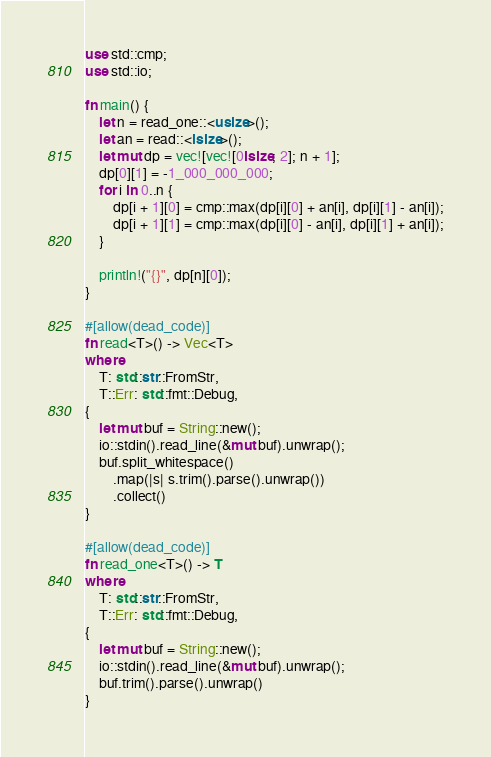<code> <loc_0><loc_0><loc_500><loc_500><_Rust_>use std::cmp;
use std::io;

fn main() {
    let n = read_one::<usize>();
    let an = read::<isize>();
    let mut dp = vec![vec![0isize; 2]; n + 1];
    dp[0][1] = -1_000_000_000;
    for i in 0..n {
        dp[i + 1][0] = cmp::max(dp[i][0] + an[i], dp[i][1] - an[i]);
        dp[i + 1][1] = cmp::max(dp[i][0] - an[i], dp[i][1] + an[i]);
    }

    println!("{}", dp[n][0]);
}

#[allow(dead_code)]
fn read<T>() -> Vec<T>
where
    T: std::str::FromStr,
    T::Err: std::fmt::Debug,
{
    let mut buf = String::new();
    io::stdin().read_line(&mut buf).unwrap();
    buf.split_whitespace()
        .map(|s| s.trim().parse().unwrap())
        .collect()
}

#[allow(dead_code)]
fn read_one<T>() -> T
where
    T: std::str::FromStr,
    T::Err: std::fmt::Debug,
{
    let mut buf = String::new();
    io::stdin().read_line(&mut buf).unwrap();
    buf.trim().parse().unwrap()
}</code> 